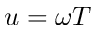Convert formula to latex. <formula><loc_0><loc_0><loc_500><loc_500>u = \omega T</formula> 